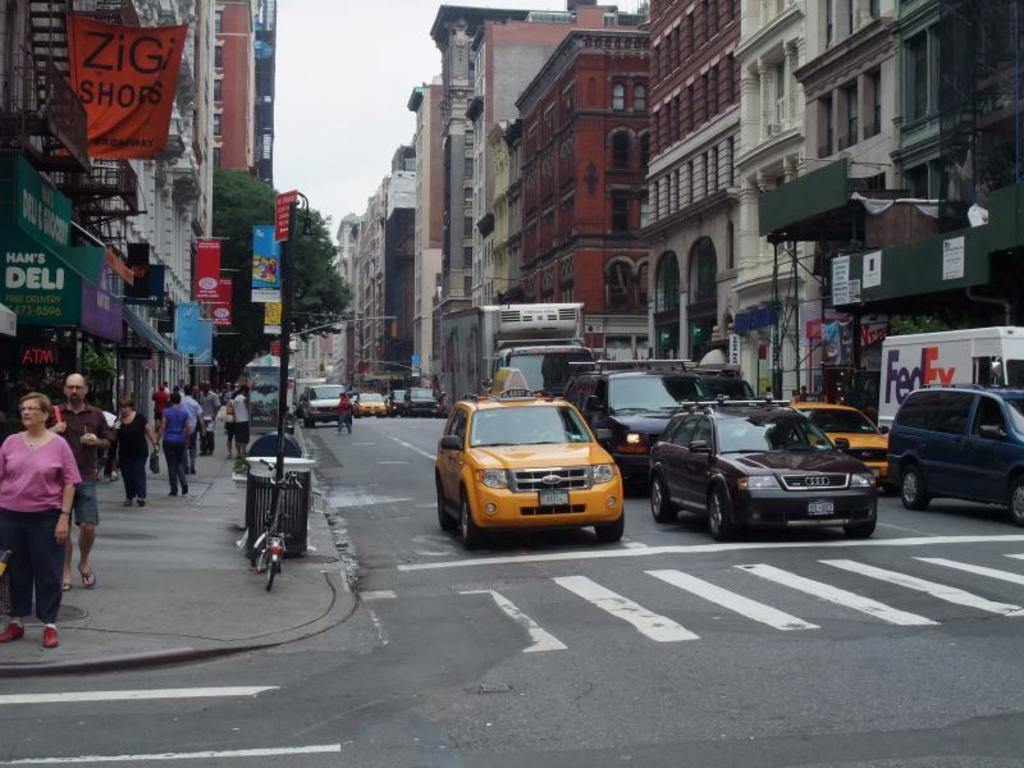<image>
Give a short and clear explanation of the subsequent image. the word zigi is on the orange sign 